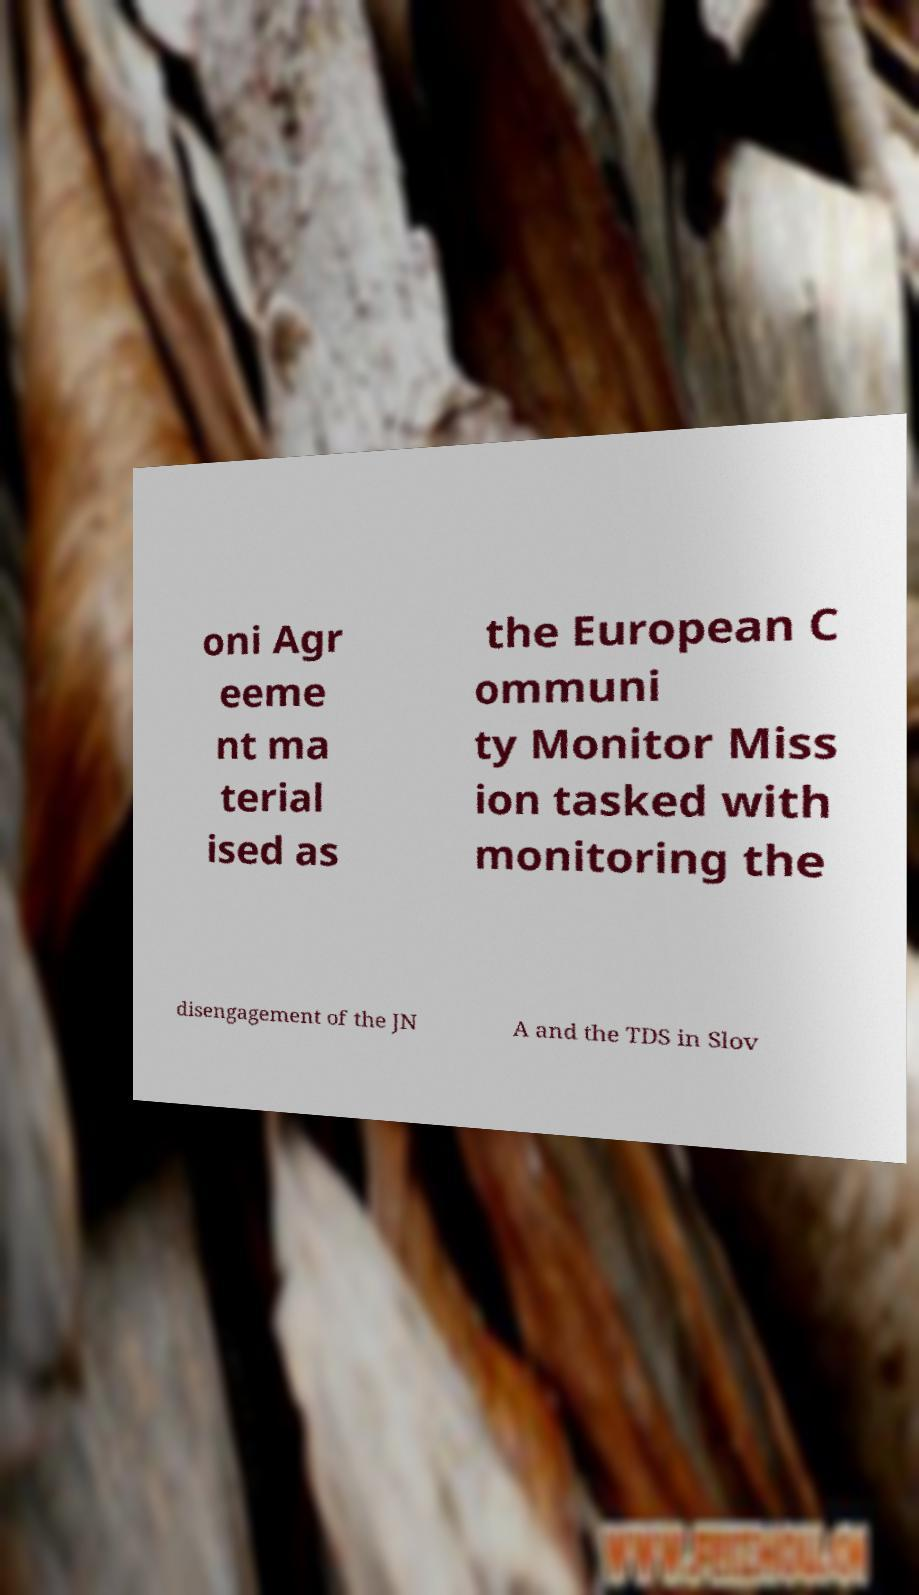Could you assist in decoding the text presented in this image and type it out clearly? oni Agr eeme nt ma terial ised as the European C ommuni ty Monitor Miss ion tasked with monitoring the disengagement of the JN A and the TDS in Slov 